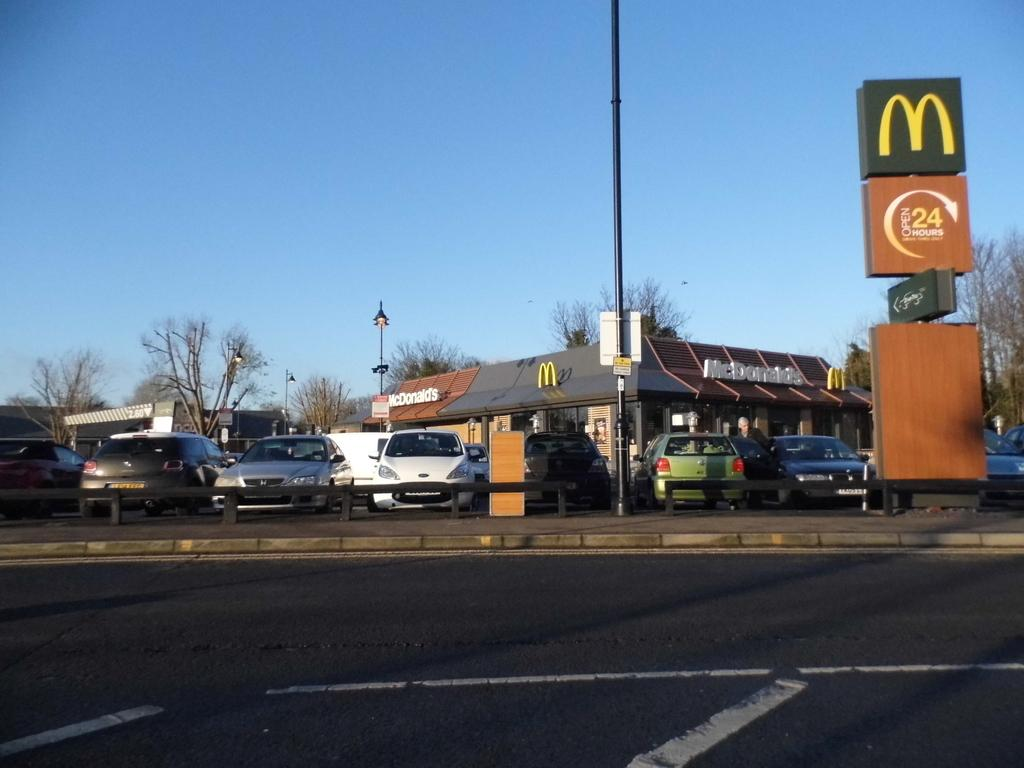What types of structures can be seen in the image? There are houses, a store, and posters in the image. What else can be found in the image besides structures? There are vehicles, poles, lights, trees, and the sky visible in the image. How many types of objects are present in the image? There are at least eight types of objects present in the image: vehicles, houses, a store, posters, poles, lights, trees, and the sky. What type of sofa is visible in the image? There is no sofa present in the image. What is being served for breakfast in the image? There is no reference to breakfast or any food in the image. 